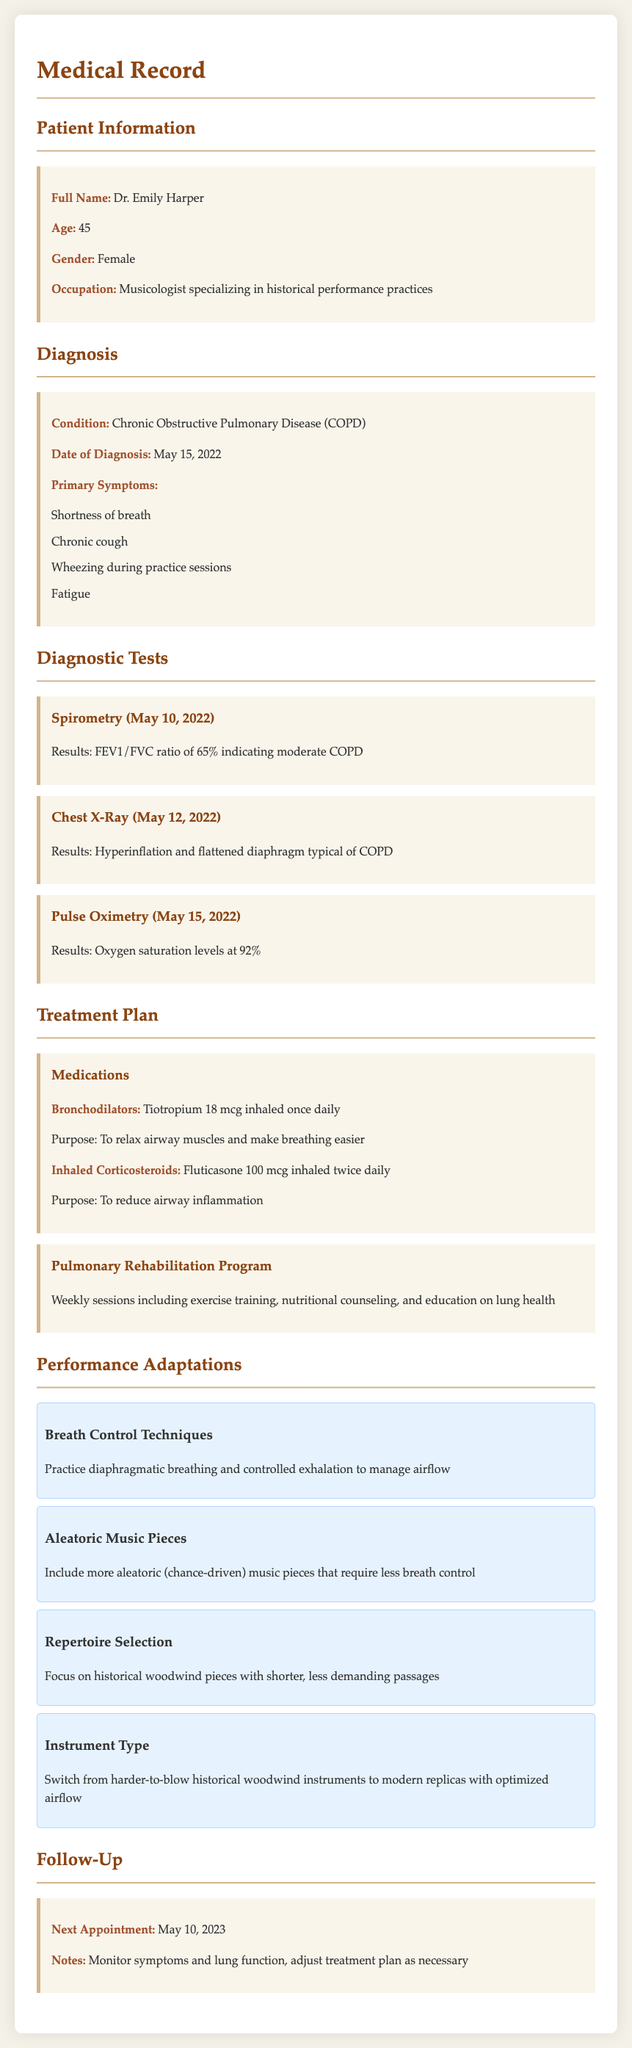What is the patient’s age? The patient's age is stated explicitly in the document.
Answer: 45 What condition was diagnosed on May 15, 2022? The diagnosis is provided in the diagnosis section of the document.
Answer: Chronic Obstructive Pulmonary Disease (COPD) What was the FEV1/FVC ratio result from the spirometry? The result of the spirometry test is given in the diagnostic tests section.
Answer: 65% Which medication is prescribed as a bronchodilator? The medication details for bronchodilators are specified in the treatment plan section.
Answer: Tiotropium 18 mcg inhaled once daily What performance adaptation is suggested for breath control? The specific performance adaptation for managing breath control is found in the performance adaptations section.
Answer: Practice diaphragmatic breathing and controlled exhalation How often are the pulmonary rehabilitation program sessions? The frequency of the pulmonary rehabilitation sessions is mentioned in the treatment plan.
Answer: Weekly sessions What is the next appointment date? The date for the follow-up appointment is clearly stated in the follow-up section.
Answer: May 10, 2023 What is one type of music piece suggested to include? The suggested type of music piece for adaptation is found in the performance adaptations section.
Answer: Aleatoric music pieces What are the primary symptoms listed for COPD? The primary symptoms of the patient's condition are listed in the diagnosis section.
Answer: Shortness of breath, chronic cough, wheezing during practice sessions, fatigue 